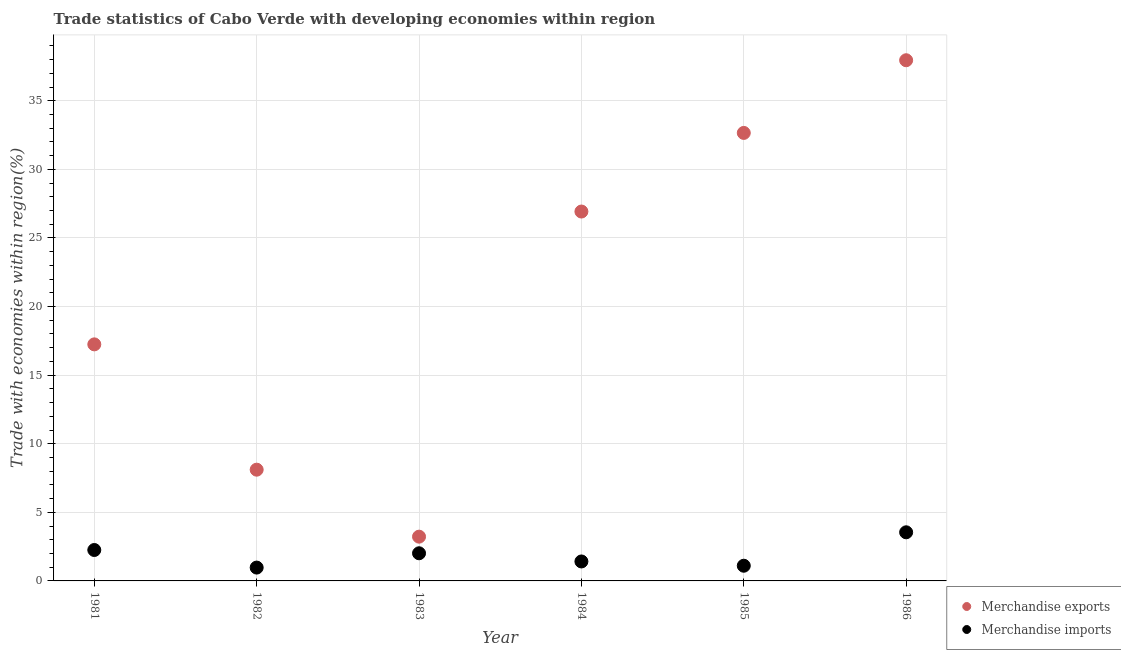What is the merchandise imports in 1986?
Offer a terse response. 3.54. Across all years, what is the maximum merchandise exports?
Your response must be concise. 37.95. Across all years, what is the minimum merchandise exports?
Offer a terse response. 3.23. In which year was the merchandise imports maximum?
Give a very brief answer. 1986. What is the total merchandise imports in the graph?
Keep it short and to the point. 11.31. What is the difference between the merchandise imports in 1981 and that in 1985?
Ensure brevity in your answer.  1.15. What is the difference between the merchandise imports in 1982 and the merchandise exports in 1986?
Provide a short and direct response. -36.98. What is the average merchandise exports per year?
Keep it short and to the point. 21.02. In the year 1983, what is the difference between the merchandise imports and merchandise exports?
Offer a terse response. -1.21. What is the ratio of the merchandise imports in 1981 to that in 1983?
Ensure brevity in your answer.  1.12. What is the difference between the highest and the second highest merchandise exports?
Provide a short and direct response. 5.3. What is the difference between the highest and the lowest merchandise imports?
Ensure brevity in your answer.  2.57. In how many years, is the merchandise exports greater than the average merchandise exports taken over all years?
Keep it short and to the point. 3. Does the merchandise imports monotonically increase over the years?
Make the answer very short. No. Is the merchandise imports strictly less than the merchandise exports over the years?
Keep it short and to the point. Yes. How many dotlines are there?
Provide a succinct answer. 2. How many years are there in the graph?
Provide a short and direct response. 6. Does the graph contain any zero values?
Offer a terse response. No. Does the graph contain grids?
Offer a very short reply. Yes. Where does the legend appear in the graph?
Provide a short and direct response. Bottom right. How many legend labels are there?
Your response must be concise. 2. How are the legend labels stacked?
Provide a short and direct response. Vertical. What is the title of the graph?
Give a very brief answer. Trade statistics of Cabo Verde with developing economies within region. Does "National Visitors" appear as one of the legend labels in the graph?
Your answer should be compact. No. What is the label or title of the X-axis?
Your answer should be very brief. Year. What is the label or title of the Y-axis?
Your response must be concise. Trade with economies within region(%). What is the Trade with economies within region(%) of Merchandise exports in 1981?
Give a very brief answer. 17.24. What is the Trade with economies within region(%) in Merchandise imports in 1981?
Provide a short and direct response. 2.25. What is the Trade with economies within region(%) of Merchandise exports in 1982?
Keep it short and to the point. 8.11. What is the Trade with economies within region(%) of Merchandise imports in 1982?
Ensure brevity in your answer.  0.97. What is the Trade with economies within region(%) of Merchandise exports in 1983?
Your answer should be compact. 3.23. What is the Trade with economies within region(%) of Merchandise imports in 1983?
Keep it short and to the point. 2.02. What is the Trade with economies within region(%) in Merchandise exports in 1984?
Provide a short and direct response. 26.92. What is the Trade with economies within region(%) in Merchandise imports in 1984?
Make the answer very short. 1.42. What is the Trade with economies within region(%) in Merchandise exports in 1985?
Provide a succinct answer. 32.65. What is the Trade with economies within region(%) in Merchandise imports in 1985?
Your answer should be very brief. 1.11. What is the Trade with economies within region(%) of Merchandise exports in 1986?
Your answer should be very brief. 37.95. What is the Trade with economies within region(%) of Merchandise imports in 1986?
Keep it short and to the point. 3.54. Across all years, what is the maximum Trade with economies within region(%) of Merchandise exports?
Make the answer very short. 37.95. Across all years, what is the maximum Trade with economies within region(%) of Merchandise imports?
Make the answer very short. 3.54. Across all years, what is the minimum Trade with economies within region(%) in Merchandise exports?
Offer a very short reply. 3.23. Across all years, what is the minimum Trade with economies within region(%) of Merchandise imports?
Your response must be concise. 0.97. What is the total Trade with economies within region(%) in Merchandise exports in the graph?
Keep it short and to the point. 126.1. What is the total Trade with economies within region(%) of Merchandise imports in the graph?
Provide a short and direct response. 11.31. What is the difference between the Trade with economies within region(%) of Merchandise exports in 1981 and that in 1982?
Provide a short and direct response. 9.13. What is the difference between the Trade with economies within region(%) of Merchandise imports in 1981 and that in 1982?
Your answer should be compact. 1.28. What is the difference between the Trade with economies within region(%) in Merchandise exports in 1981 and that in 1983?
Give a very brief answer. 14.02. What is the difference between the Trade with economies within region(%) in Merchandise imports in 1981 and that in 1983?
Keep it short and to the point. 0.24. What is the difference between the Trade with economies within region(%) in Merchandise exports in 1981 and that in 1984?
Provide a short and direct response. -9.68. What is the difference between the Trade with economies within region(%) in Merchandise imports in 1981 and that in 1984?
Make the answer very short. 0.84. What is the difference between the Trade with economies within region(%) of Merchandise exports in 1981 and that in 1985?
Your answer should be compact. -15.41. What is the difference between the Trade with economies within region(%) of Merchandise imports in 1981 and that in 1985?
Your response must be concise. 1.15. What is the difference between the Trade with economies within region(%) of Merchandise exports in 1981 and that in 1986?
Keep it short and to the point. -20.71. What is the difference between the Trade with economies within region(%) of Merchandise imports in 1981 and that in 1986?
Your answer should be very brief. -1.29. What is the difference between the Trade with economies within region(%) of Merchandise exports in 1982 and that in 1983?
Your answer should be compact. 4.88. What is the difference between the Trade with economies within region(%) in Merchandise imports in 1982 and that in 1983?
Provide a short and direct response. -1.04. What is the difference between the Trade with economies within region(%) of Merchandise exports in 1982 and that in 1984?
Give a very brief answer. -18.82. What is the difference between the Trade with economies within region(%) of Merchandise imports in 1982 and that in 1984?
Make the answer very short. -0.45. What is the difference between the Trade with economies within region(%) of Merchandise exports in 1982 and that in 1985?
Provide a succinct answer. -24.55. What is the difference between the Trade with economies within region(%) of Merchandise imports in 1982 and that in 1985?
Make the answer very short. -0.13. What is the difference between the Trade with economies within region(%) in Merchandise exports in 1982 and that in 1986?
Offer a terse response. -29.84. What is the difference between the Trade with economies within region(%) in Merchandise imports in 1982 and that in 1986?
Your response must be concise. -2.57. What is the difference between the Trade with economies within region(%) in Merchandise exports in 1983 and that in 1984?
Give a very brief answer. -23.7. What is the difference between the Trade with economies within region(%) in Merchandise imports in 1983 and that in 1984?
Provide a succinct answer. 0.6. What is the difference between the Trade with economies within region(%) in Merchandise exports in 1983 and that in 1985?
Provide a short and direct response. -29.43. What is the difference between the Trade with economies within region(%) in Merchandise imports in 1983 and that in 1985?
Ensure brevity in your answer.  0.91. What is the difference between the Trade with economies within region(%) in Merchandise exports in 1983 and that in 1986?
Make the answer very short. -34.72. What is the difference between the Trade with economies within region(%) of Merchandise imports in 1983 and that in 1986?
Give a very brief answer. -1.53. What is the difference between the Trade with economies within region(%) of Merchandise exports in 1984 and that in 1985?
Provide a succinct answer. -5.73. What is the difference between the Trade with economies within region(%) in Merchandise imports in 1984 and that in 1985?
Make the answer very short. 0.31. What is the difference between the Trade with economies within region(%) of Merchandise exports in 1984 and that in 1986?
Your answer should be very brief. -11.03. What is the difference between the Trade with economies within region(%) in Merchandise imports in 1984 and that in 1986?
Keep it short and to the point. -2.13. What is the difference between the Trade with economies within region(%) in Merchandise exports in 1985 and that in 1986?
Provide a short and direct response. -5.3. What is the difference between the Trade with economies within region(%) of Merchandise imports in 1985 and that in 1986?
Ensure brevity in your answer.  -2.44. What is the difference between the Trade with economies within region(%) of Merchandise exports in 1981 and the Trade with economies within region(%) of Merchandise imports in 1982?
Provide a succinct answer. 16.27. What is the difference between the Trade with economies within region(%) of Merchandise exports in 1981 and the Trade with economies within region(%) of Merchandise imports in 1983?
Your answer should be very brief. 15.23. What is the difference between the Trade with economies within region(%) of Merchandise exports in 1981 and the Trade with economies within region(%) of Merchandise imports in 1984?
Your answer should be compact. 15.82. What is the difference between the Trade with economies within region(%) of Merchandise exports in 1981 and the Trade with economies within region(%) of Merchandise imports in 1985?
Offer a very short reply. 16.13. What is the difference between the Trade with economies within region(%) of Merchandise exports in 1981 and the Trade with economies within region(%) of Merchandise imports in 1986?
Ensure brevity in your answer.  13.7. What is the difference between the Trade with economies within region(%) in Merchandise exports in 1982 and the Trade with economies within region(%) in Merchandise imports in 1983?
Offer a very short reply. 6.09. What is the difference between the Trade with economies within region(%) in Merchandise exports in 1982 and the Trade with economies within region(%) in Merchandise imports in 1984?
Ensure brevity in your answer.  6.69. What is the difference between the Trade with economies within region(%) in Merchandise exports in 1982 and the Trade with economies within region(%) in Merchandise imports in 1985?
Provide a succinct answer. 7. What is the difference between the Trade with economies within region(%) in Merchandise exports in 1982 and the Trade with economies within region(%) in Merchandise imports in 1986?
Offer a very short reply. 4.56. What is the difference between the Trade with economies within region(%) of Merchandise exports in 1983 and the Trade with economies within region(%) of Merchandise imports in 1984?
Make the answer very short. 1.81. What is the difference between the Trade with economies within region(%) in Merchandise exports in 1983 and the Trade with economies within region(%) in Merchandise imports in 1985?
Your response must be concise. 2.12. What is the difference between the Trade with economies within region(%) of Merchandise exports in 1983 and the Trade with economies within region(%) of Merchandise imports in 1986?
Your answer should be very brief. -0.32. What is the difference between the Trade with economies within region(%) of Merchandise exports in 1984 and the Trade with economies within region(%) of Merchandise imports in 1985?
Offer a terse response. 25.82. What is the difference between the Trade with economies within region(%) in Merchandise exports in 1984 and the Trade with economies within region(%) in Merchandise imports in 1986?
Give a very brief answer. 23.38. What is the difference between the Trade with economies within region(%) in Merchandise exports in 1985 and the Trade with economies within region(%) in Merchandise imports in 1986?
Your answer should be compact. 29.11. What is the average Trade with economies within region(%) of Merchandise exports per year?
Your answer should be compact. 21.02. What is the average Trade with economies within region(%) in Merchandise imports per year?
Your answer should be very brief. 1.89. In the year 1981, what is the difference between the Trade with economies within region(%) in Merchandise exports and Trade with economies within region(%) in Merchandise imports?
Provide a short and direct response. 14.99. In the year 1982, what is the difference between the Trade with economies within region(%) in Merchandise exports and Trade with economies within region(%) in Merchandise imports?
Provide a succinct answer. 7.14. In the year 1983, what is the difference between the Trade with economies within region(%) in Merchandise exports and Trade with economies within region(%) in Merchandise imports?
Keep it short and to the point. 1.21. In the year 1984, what is the difference between the Trade with economies within region(%) of Merchandise exports and Trade with economies within region(%) of Merchandise imports?
Keep it short and to the point. 25.5. In the year 1985, what is the difference between the Trade with economies within region(%) in Merchandise exports and Trade with economies within region(%) in Merchandise imports?
Ensure brevity in your answer.  31.55. In the year 1986, what is the difference between the Trade with economies within region(%) in Merchandise exports and Trade with economies within region(%) in Merchandise imports?
Make the answer very short. 34.41. What is the ratio of the Trade with economies within region(%) of Merchandise exports in 1981 to that in 1982?
Give a very brief answer. 2.13. What is the ratio of the Trade with economies within region(%) of Merchandise imports in 1981 to that in 1982?
Your answer should be compact. 2.32. What is the ratio of the Trade with economies within region(%) of Merchandise exports in 1981 to that in 1983?
Offer a very short reply. 5.34. What is the ratio of the Trade with economies within region(%) of Merchandise imports in 1981 to that in 1983?
Provide a short and direct response. 1.12. What is the ratio of the Trade with economies within region(%) in Merchandise exports in 1981 to that in 1984?
Keep it short and to the point. 0.64. What is the ratio of the Trade with economies within region(%) in Merchandise imports in 1981 to that in 1984?
Your answer should be compact. 1.59. What is the ratio of the Trade with economies within region(%) in Merchandise exports in 1981 to that in 1985?
Ensure brevity in your answer.  0.53. What is the ratio of the Trade with economies within region(%) in Merchandise imports in 1981 to that in 1985?
Offer a very short reply. 2.04. What is the ratio of the Trade with economies within region(%) in Merchandise exports in 1981 to that in 1986?
Keep it short and to the point. 0.45. What is the ratio of the Trade with economies within region(%) of Merchandise imports in 1981 to that in 1986?
Provide a short and direct response. 0.64. What is the ratio of the Trade with economies within region(%) in Merchandise exports in 1982 to that in 1983?
Offer a very short reply. 2.51. What is the ratio of the Trade with economies within region(%) of Merchandise imports in 1982 to that in 1983?
Your response must be concise. 0.48. What is the ratio of the Trade with economies within region(%) in Merchandise exports in 1982 to that in 1984?
Provide a succinct answer. 0.3. What is the ratio of the Trade with economies within region(%) of Merchandise imports in 1982 to that in 1984?
Offer a terse response. 0.69. What is the ratio of the Trade with economies within region(%) in Merchandise exports in 1982 to that in 1985?
Your answer should be compact. 0.25. What is the ratio of the Trade with economies within region(%) in Merchandise imports in 1982 to that in 1985?
Offer a terse response. 0.88. What is the ratio of the Trade with economies within region(%) in Merchandise exports in 1982 to that in 1986?
Your answer should be compact. 0.21. What is the ratio of the Trade with economies within region(%) of Merchandise imports in 1982 to that in 1986?
Provide a short and direct response. 0.27. What is the ratio of the Trade with economies within region(%) of Merchandise exports in 1983 to that in 1984?
Make the answer very short. 0.12. What is the ratio of the Trade with economies within region(%) of Merchandise imports in 1983 to that in 1984?
Offer a very short reply. 1.42. What is the ratio of the Trade with economies within region(%) of Merchandise exports in 1983 to that in 1985?
Keep it short and to the point. 0.1. What is the ratio of the Trade with economies within region(%) of Merchandise imports in 1983 to that in 1985?
Your answer should be compact. 1.82. What is the ratio of the Trade with economies within region(%) of Merchandise exports in 1983 to that in 1986?
Make the answer very short. 0.09. What is the ratio of the Trade with economies within region(%) of Merchandise imports in 1983 to that in 1986?
Keep it short and to the point. 0.57. What is the ratio of the Trade with economies within region(%) of Merchandise exports in 1984 to that in 1985?
Keep it short and to the point. 0.82. What is the ratio of the Trade with economies within region(%) of Merchandise imports in 1984 to that in 1985?
Give a very brief answer. 1.28. What is the ratio of the Trade with economies within region(%) of Merchandise exports in 1984 to that in 1986?
Provide a short and direct response. 0.71. What is the ratio of the Trade with economies within region(%) in Merchandise imports in 1984 to that in 1986?
Provide a succinct answer. 0.4. What is the ratio of the Trade with economies within region(%) in Merchandise exports in 1985 to that in 1986?
Give a very brief answer. 0.86. What is the ratio of the Trade with economies within region(%) of Merchandise imports in 1985 to that in 1986?
Make the answer very short. 0.31. What is the difference between the highest and the second highest Trade with economies within region(%) of Merchandise exports?
Provide a succinct answer. 5.3. What is the difference between the highest and the second highest Trade with economies within region(%) in Merchandise imports?
Provide a short and direct response. 1.29. What is the difference between the highest and the lowest Trade with economies within region(%) in Merchandise exports?
Provide a succinct answer. 34.72. What is the difference between the highest and the lowest Trade with economies within region(%) in Merchandise imports?
Give a very brief answer. 2.57. 